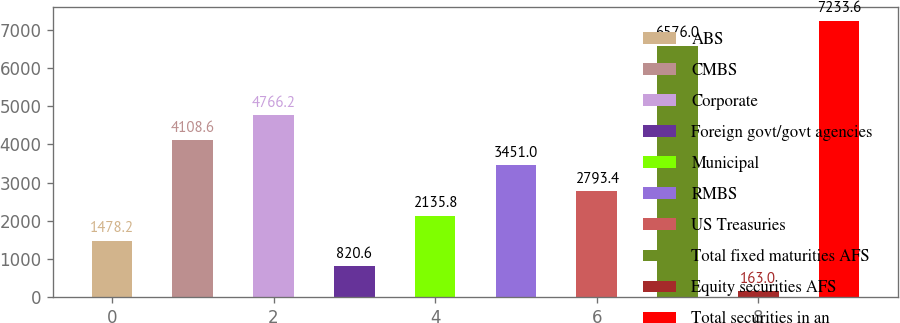Convert chart to OTSL. <chart><loc_0><loc_0><loc_500><loc_500><bar_chart><fcel>ABS<fcel>CMBS<fcel>Corporate<fcel>Foreign govt/govt agencies<fcel>Municipal<fcel>RMBS<fcel>US Treasuries<fcel>Total fixed maturities AFS<fcel>Equity securities AFS<fcel>Total securities in an<nl><fcel>1478.2<fcel>4108.6<fcel>4766.2<fcel>820.6<fcel>2135.8<fcel>3451<fcel>2793.4<fcel>6576<fcel>163<fcel>7233.6<nl></chart> 